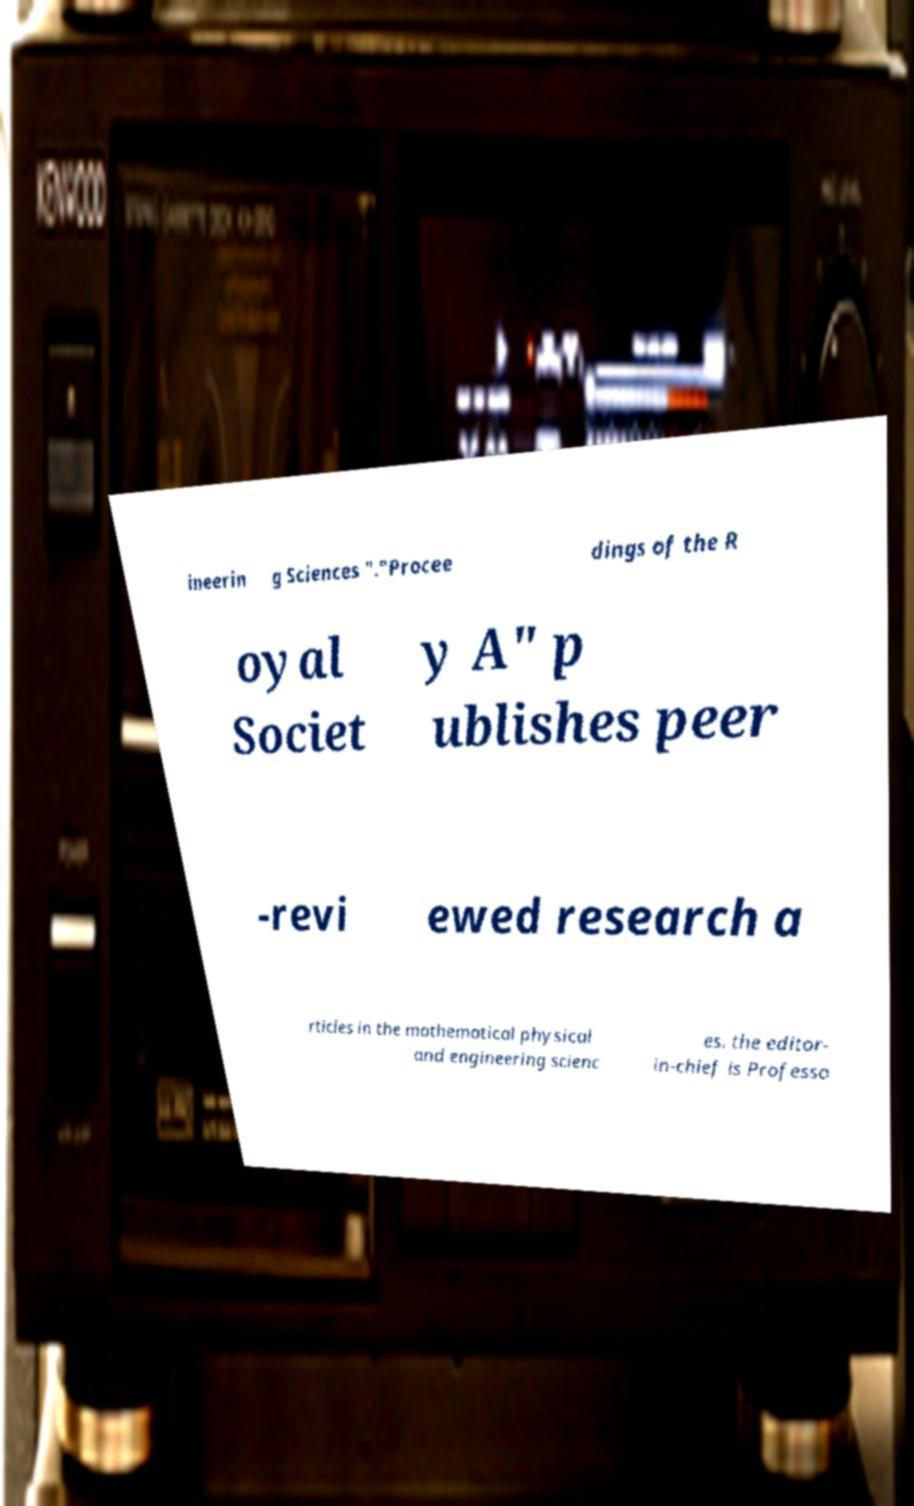Could you assist in decoding the text presented in this image and type it out clearly? ineerin g Sciences "."Procee dings of the R oyal Societ y A" p ublishes peer -revi ewed research a rticles in the mathematical physical and engineering scienc es. the editor- in-chief is Professo 